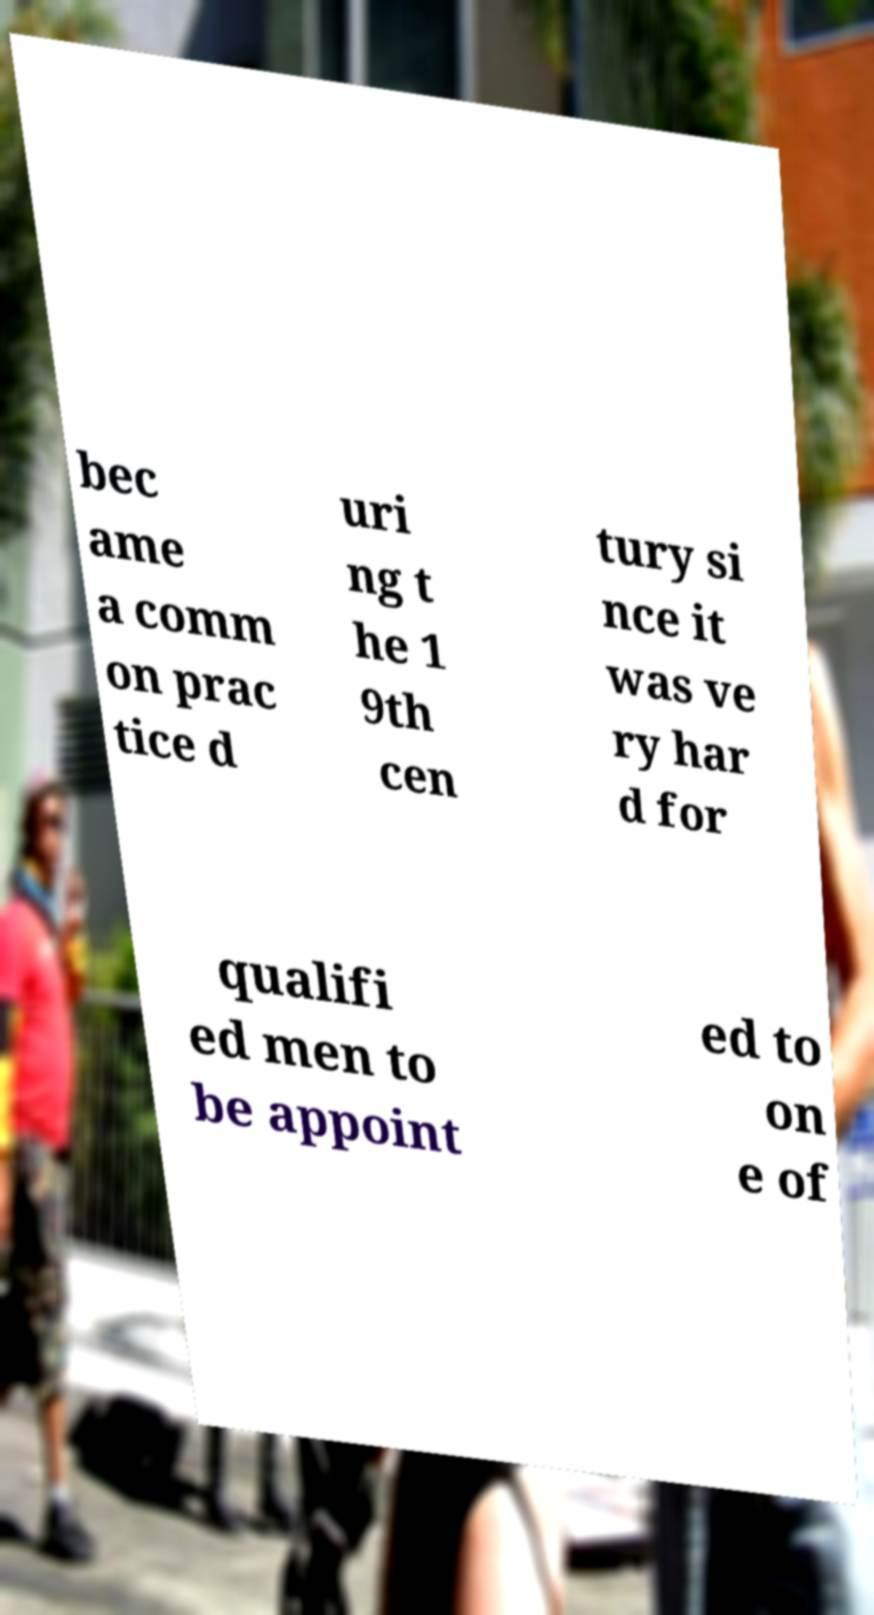Can you accurately transcribe the text from the provided image for me? bec ame a comm on prac tice d uri ng t he 1 9th cen tury si nce it was ve ry har d for qualifi ed men to be appoint ed to on e of 